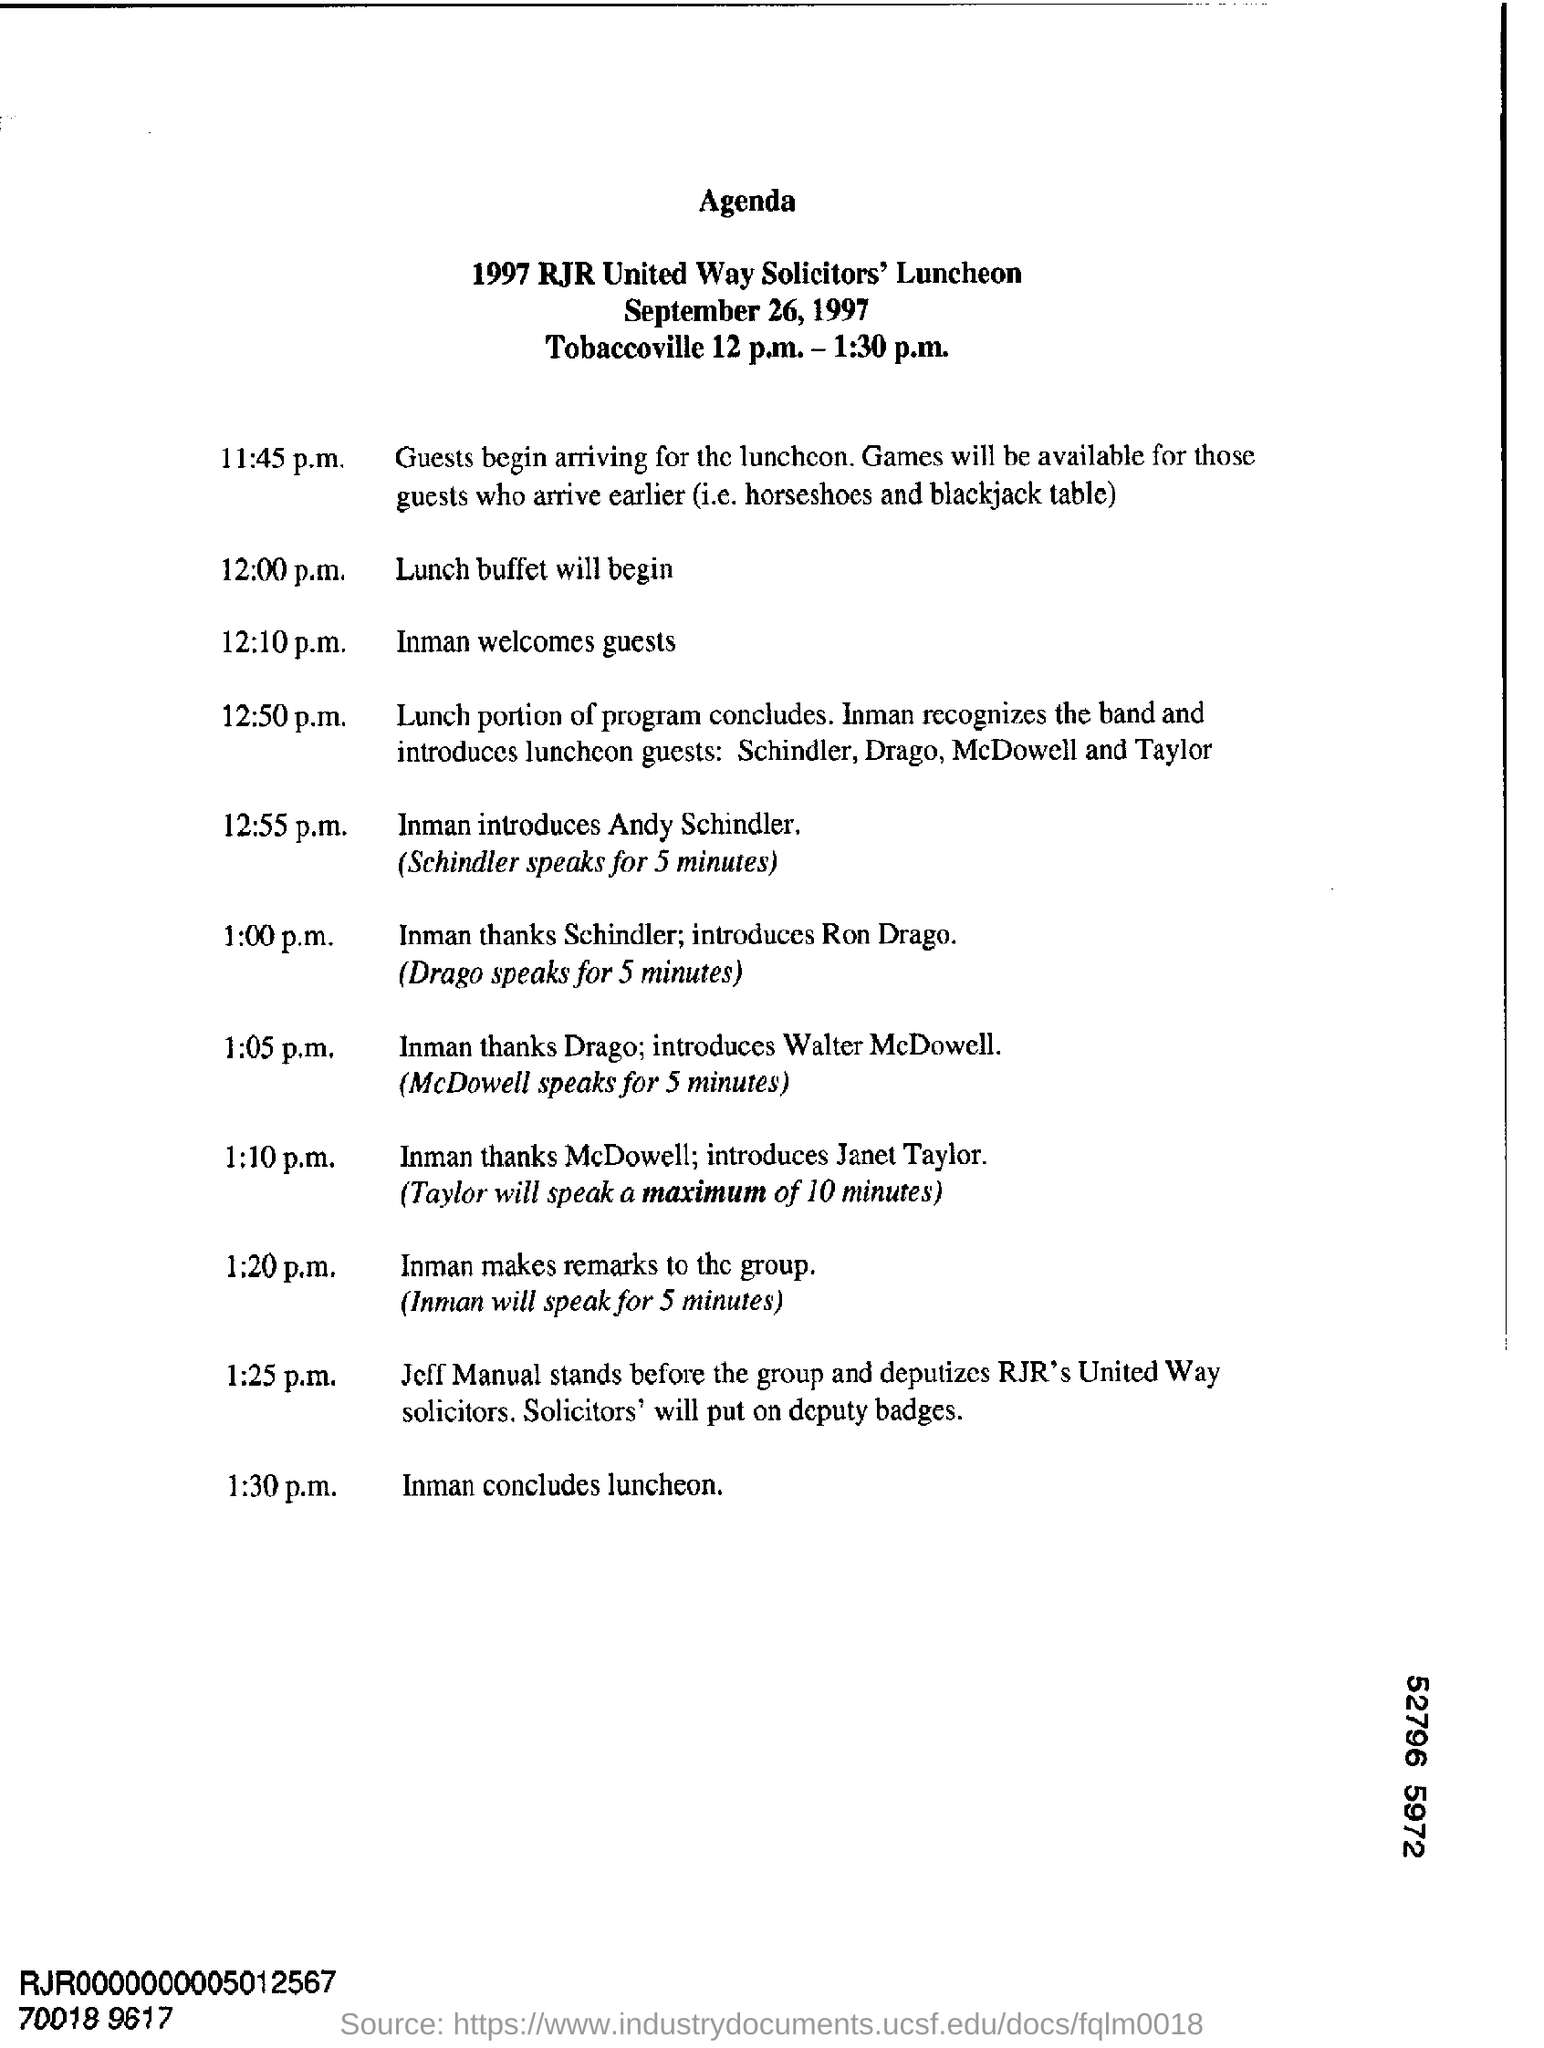What is the agenda for?
Offer a terse response. 1997 RJR United Way Solicitors' Luncheon. Who does Inman introduce at 12:55 p.m.?
Provide a succinct answer. Schindler. 